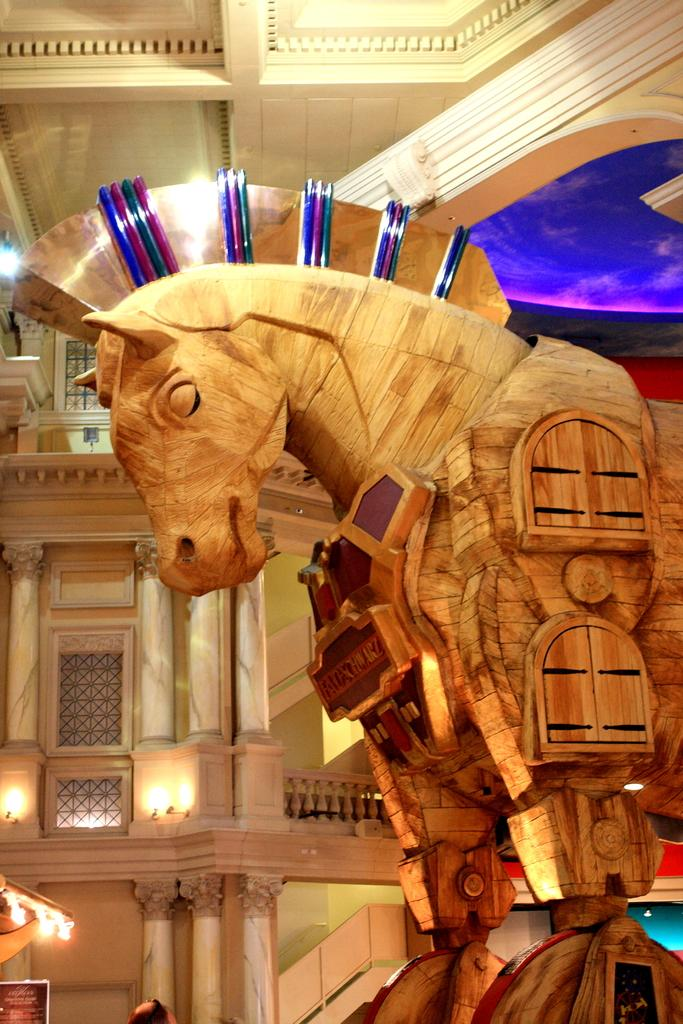What is the main subject of the image? The main subject of the image is a wooden horse sculpture. Can you describe the setting in which the wooden horse sculpture is located? The wooden horse sculpture is inside a building. How many bananas are hanging from the wooden horse sculpture in the image? There are no bananas present in the image, as it features a wooden horse sculpture inside a building. Can you spot any ladybugs crawling on the wooden horse sculpture in the image? There are no ladybugs visible on the wooden horse sculpture in the image. 